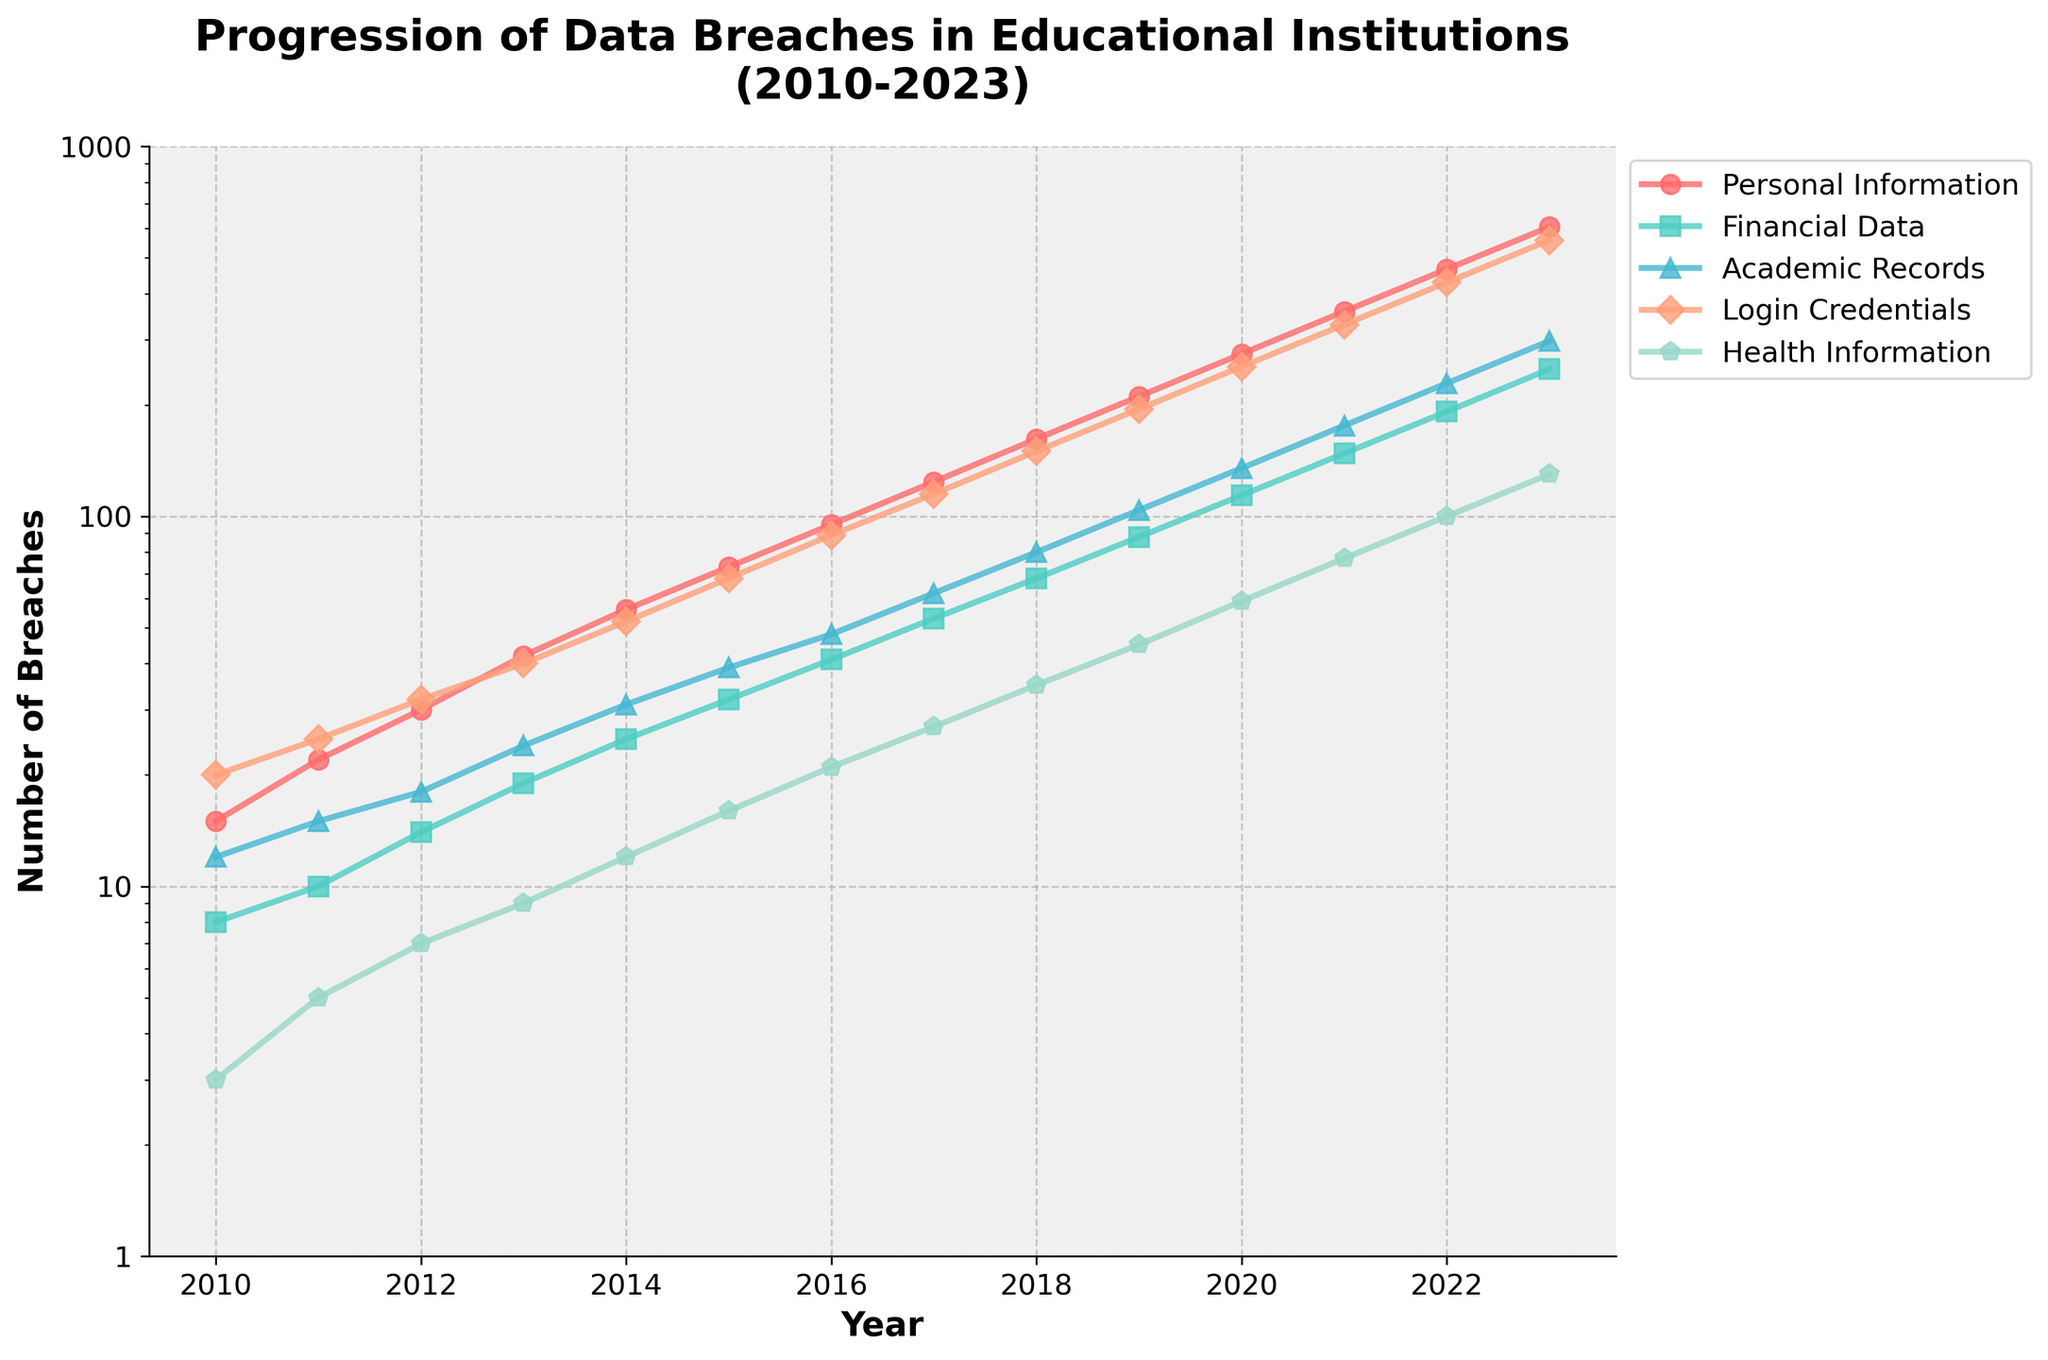Which year saw the highest number of data breaches related to login credentials? To find the year with the highest number of breaches in login credentials, examine the line representing Login Credentials in the figure and identify the peak point. The peak occurs in 2023.
Answer: 2023 Between which years did the number of breaches involving health information experience the highest growth? First, calculate the difference in the number of breaches between consecutive years for health information. The largest increase is between 2022 and 2023 (130 - 100 = 30).
Answer: 2022-2023 How does the number of academic record breaches in 2013 compare to personal information breaches in the same year? Look at the chart for 2013 values. Academic Records have 24 breaches, and Personal Information has 42 breaches. Therefore, Personal Information breaches are higher.
Answer: Personal Information is higher What is the average number of personal information breaches from 2017 to 2020? First, sum the number of personal information breaches from 2017 (124), 2018 (162), 2019 (211), and 2020 (275). Then find the average: (124 + 162 + 211 + 275) / 4 = 193.
Answer: 193 Which type of information had the least number of breaches in 2015? Examine the chart for 2015 and identify the category with the lowest breach numbers. Health Information has the lowest value at 16 breaches.
Answer: Health Information What is the total number of financial data breaches from 2021 to 2023? Add the number of financial data breaches from 2021 (148), 2022 (192), and 2023 (250): 148 + 192 + 250 = 590.
Answer: 590 By how much did the number of login credential breaches change from 2019 to 2021? Calculate the difference in the number of login credential breaches between 2019 (195) and 2021 (330): 330 - 195 = 135.
Answer: 135 In which year did academic records breaches first surpass 100? Check the graph for the first year where the Academic Records line crosses the 100 mark. This happens in 2019.
Answer: 2019 What is the overall trend for financial data breaches from 2010 to 2023? Observe the line corresponding to Financial Data from 2010 to 2023. The trend shows a consistent increase over the years.
Answer: Increasing 